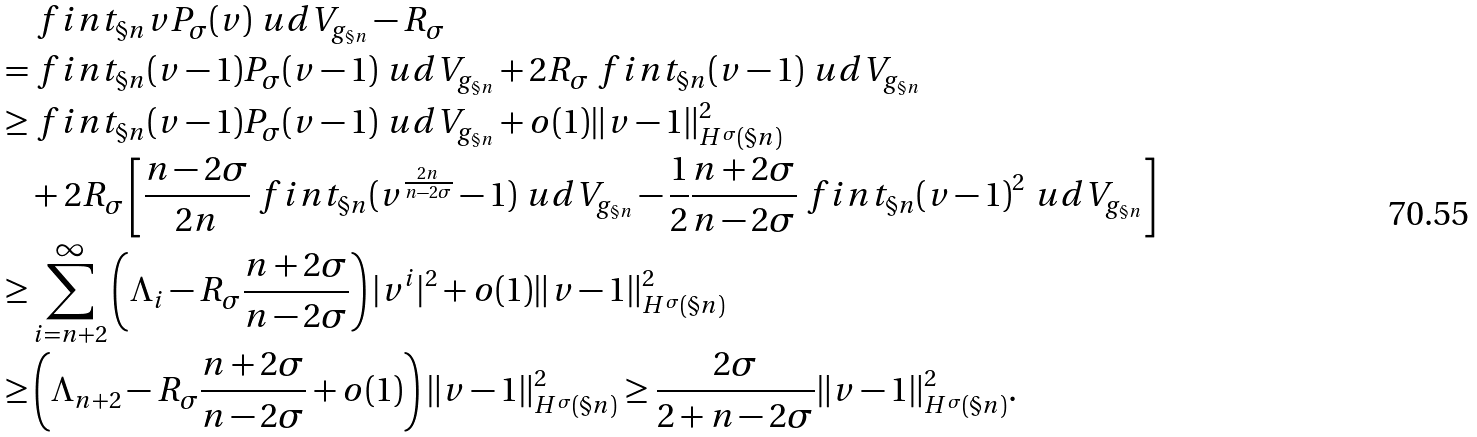Convert formula to latex. <formula><loc_0><loc_0><loc_500><loc_500>& \ f i n t _ { \S n } v P _ { \sigma } ( v ) \ u d V _ { g _ { \S n } } - R _ { \sigma } \\ = & \ f i n t _ { \S n } ( v - 1 ) P _ { \sigma } ( v - 1 ) \ u d V _ { g _ { \S n } } + 2 R _ { \sigma } \ f i n t _ { \S n } ( v - 1 ) \ u d V _ { g _ { \S n } } \\ \geq & \ f i n t _ { \S n } ( v - 1 ) P _ { \sigma } ( v - 1 ) \ u d V _ { g _ { \S n } } + o ( 1 ) \| v - 1 \| _ { H ^ { \sigma } ( \S n ) } ^ { 2 } \\ & + 2 R _ { \sigma } \left [ \frac { n - 2 \sigma } { 2 n } \ f i n t _ { \S n } ( v ^ { \frac { 2 n } { n - 2 \sigma } } - 1 ) \ u d V _ { g _ { \S n } } - \frac { 1 } { 2 } \frac { n + 2 \sigma } { n - 2 \sigma } \ f i n t _ { \S n } ( v - 1 ) ^ { 2 } \ u d V _ { g _ { \S n } } \right ] \\ \geq & \sum _ { i = n + 2 } ^ { \infty } \left ( \Lambda _ { i } - R _ { \sigma } \frac { n + 2 \sigma } { n - 2 \sigma } \right ) | v ^ { i } | ^ { 2 } + o ( 1 ) \| v - 1 \| _ { H ^ { \sigma } ( \S n ) } ^ { 2 } \\ \geq & \left ( \Lambda _ { n + 2 } - R _ { \sigma } \frac { n + 2 \sigma } { n - 2 \sigma } + o ( 1 ) \right ) \| v - 1 \| _ { H ^ { \sigma } ( \S n ) } ^ { 2 } \geq \frac { 2 \sigma } { 2 + n - 2 \sigma } \| v - 1 \| _ { H ^ { \sigma } ( \S n ) } ^ { 2 } .</formula> 